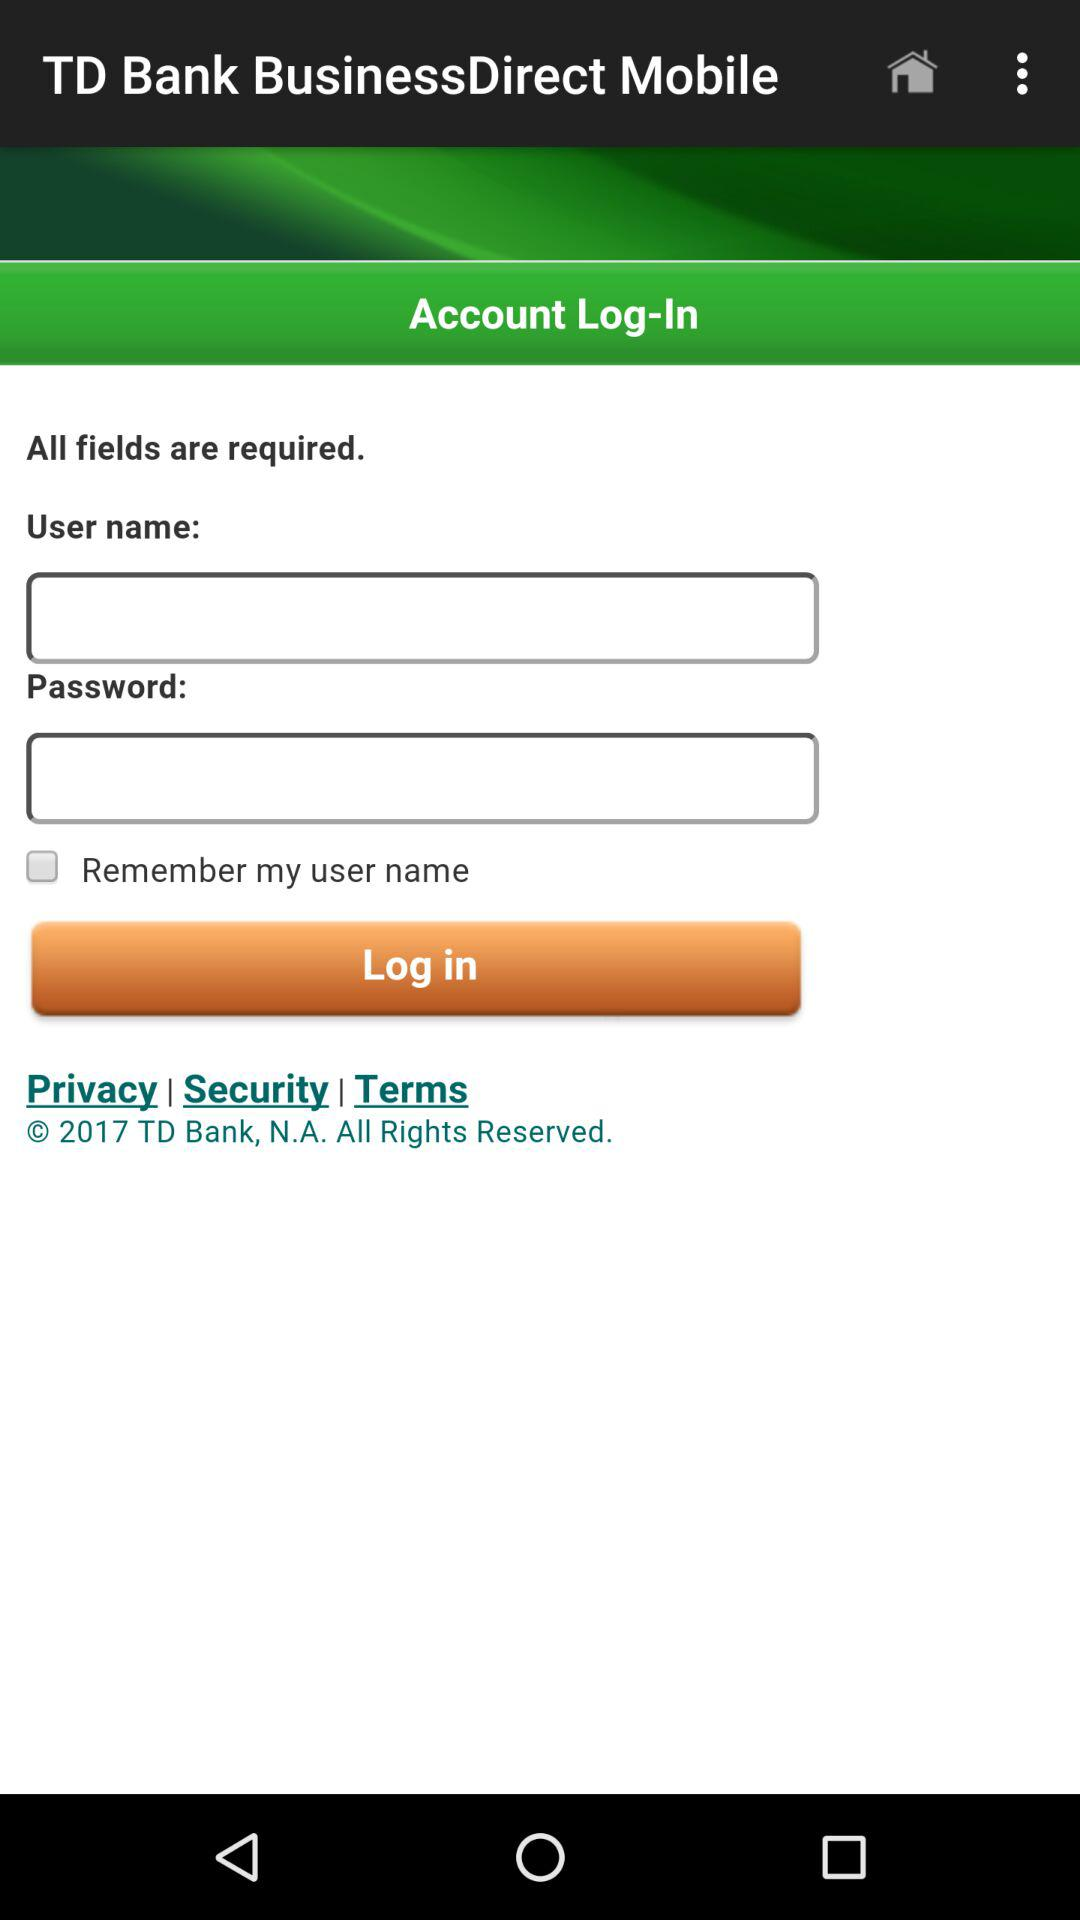What company has all rights reserved? The company "TD Bank, N.A." has all rights reserved. 